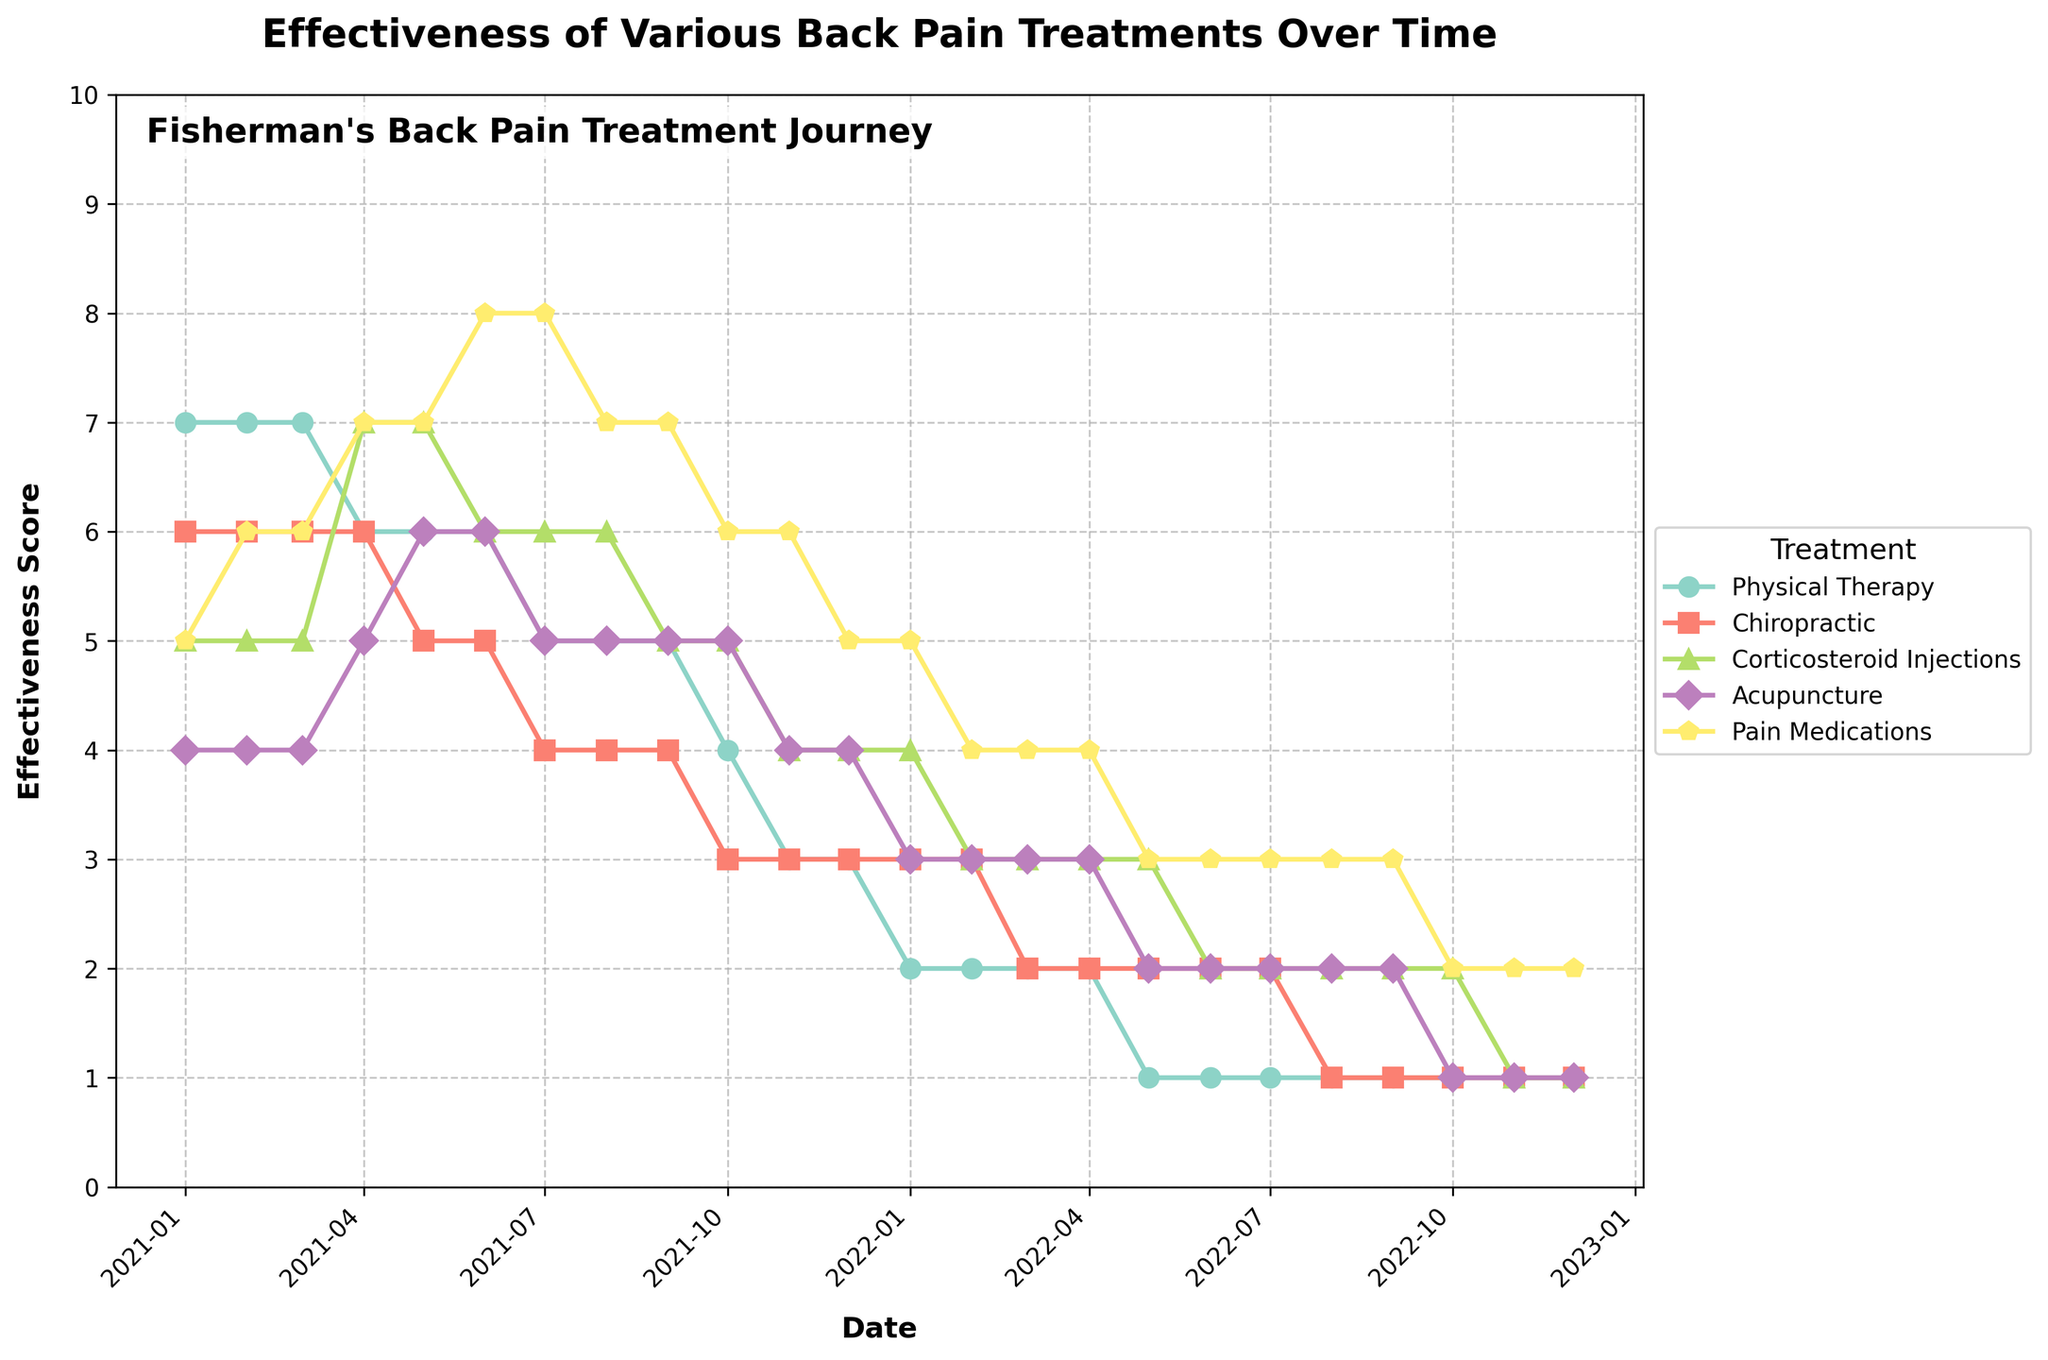Which treatment was the most effective overall in January 2021? According to the figure, the highest effectiveness score in January 2021 was for Physical Therapy which had a score of 7.
Answer: Physical Therapy How did the effectiveness of Pain Medications change from January 2021 to December 2022? The effectiveness of Pain Medications increased from a score of 5 in January 2021 to a score of 2 in December 2022. There is an initial gradual increase and then a steady decline.
Answer: Increased then decreased Which treatment showed the most dramatic decline in effectiveness over the time period shown? Both Physical Therapy and Chiropractic treatments showed notable declines. Physical Therapy decreased from 7 to 1 and Chiropractic also had a similar drop from 6 to 1.
Answer: Physical Therapy and Chiropractic In which month did the effectiveness of Corticosteroid Injections first exceed the effectiveness of Physical Therapy? In April 2021, the effectiveness of Corticosteroid Injections surpassed Physical Therapy for the first time. Corticosteroid Injections increased to a score of 7, while Physical Therapy decreased to 6.
Answer: April 2021 By how much did the effectiveness of Acupuncture increase from April 2021 to May 2021? The effectiveness of Acupuncture increased from a score of 5 in April 2021 to a score of 6 in May 2021. The increase is by 1 point.
Answer: 1 point Which treatments had a consistent downward trend over the time period shown? Physical Therapy, Chiropractic, and Corticosteroid Injections all show consistent downward trends. The graph indicates a steady decline without significant upward movement.
Answer: Physical Therapy, Chiropractic, Corticosteroid Injections In which month did Pain Medications reach their peak effectiveness? Pain Medications reached their peak effectiveness in June and July 2021, with a score of 8.
Answer: June and July 2021 What was the effectiveness score of Physical Therapy in December 2021? In December 2021, the effectiveness of Physical Therapy was recorded as 3 according to the graph.
Answer: 3 How did the effectiveness of Acupuncture change between June 2021 and July 2021? The effectiveness of Acupuncture decreased from 6 in June 2021 to 5 in July 2021.
Answer: Decreased by 1 point 